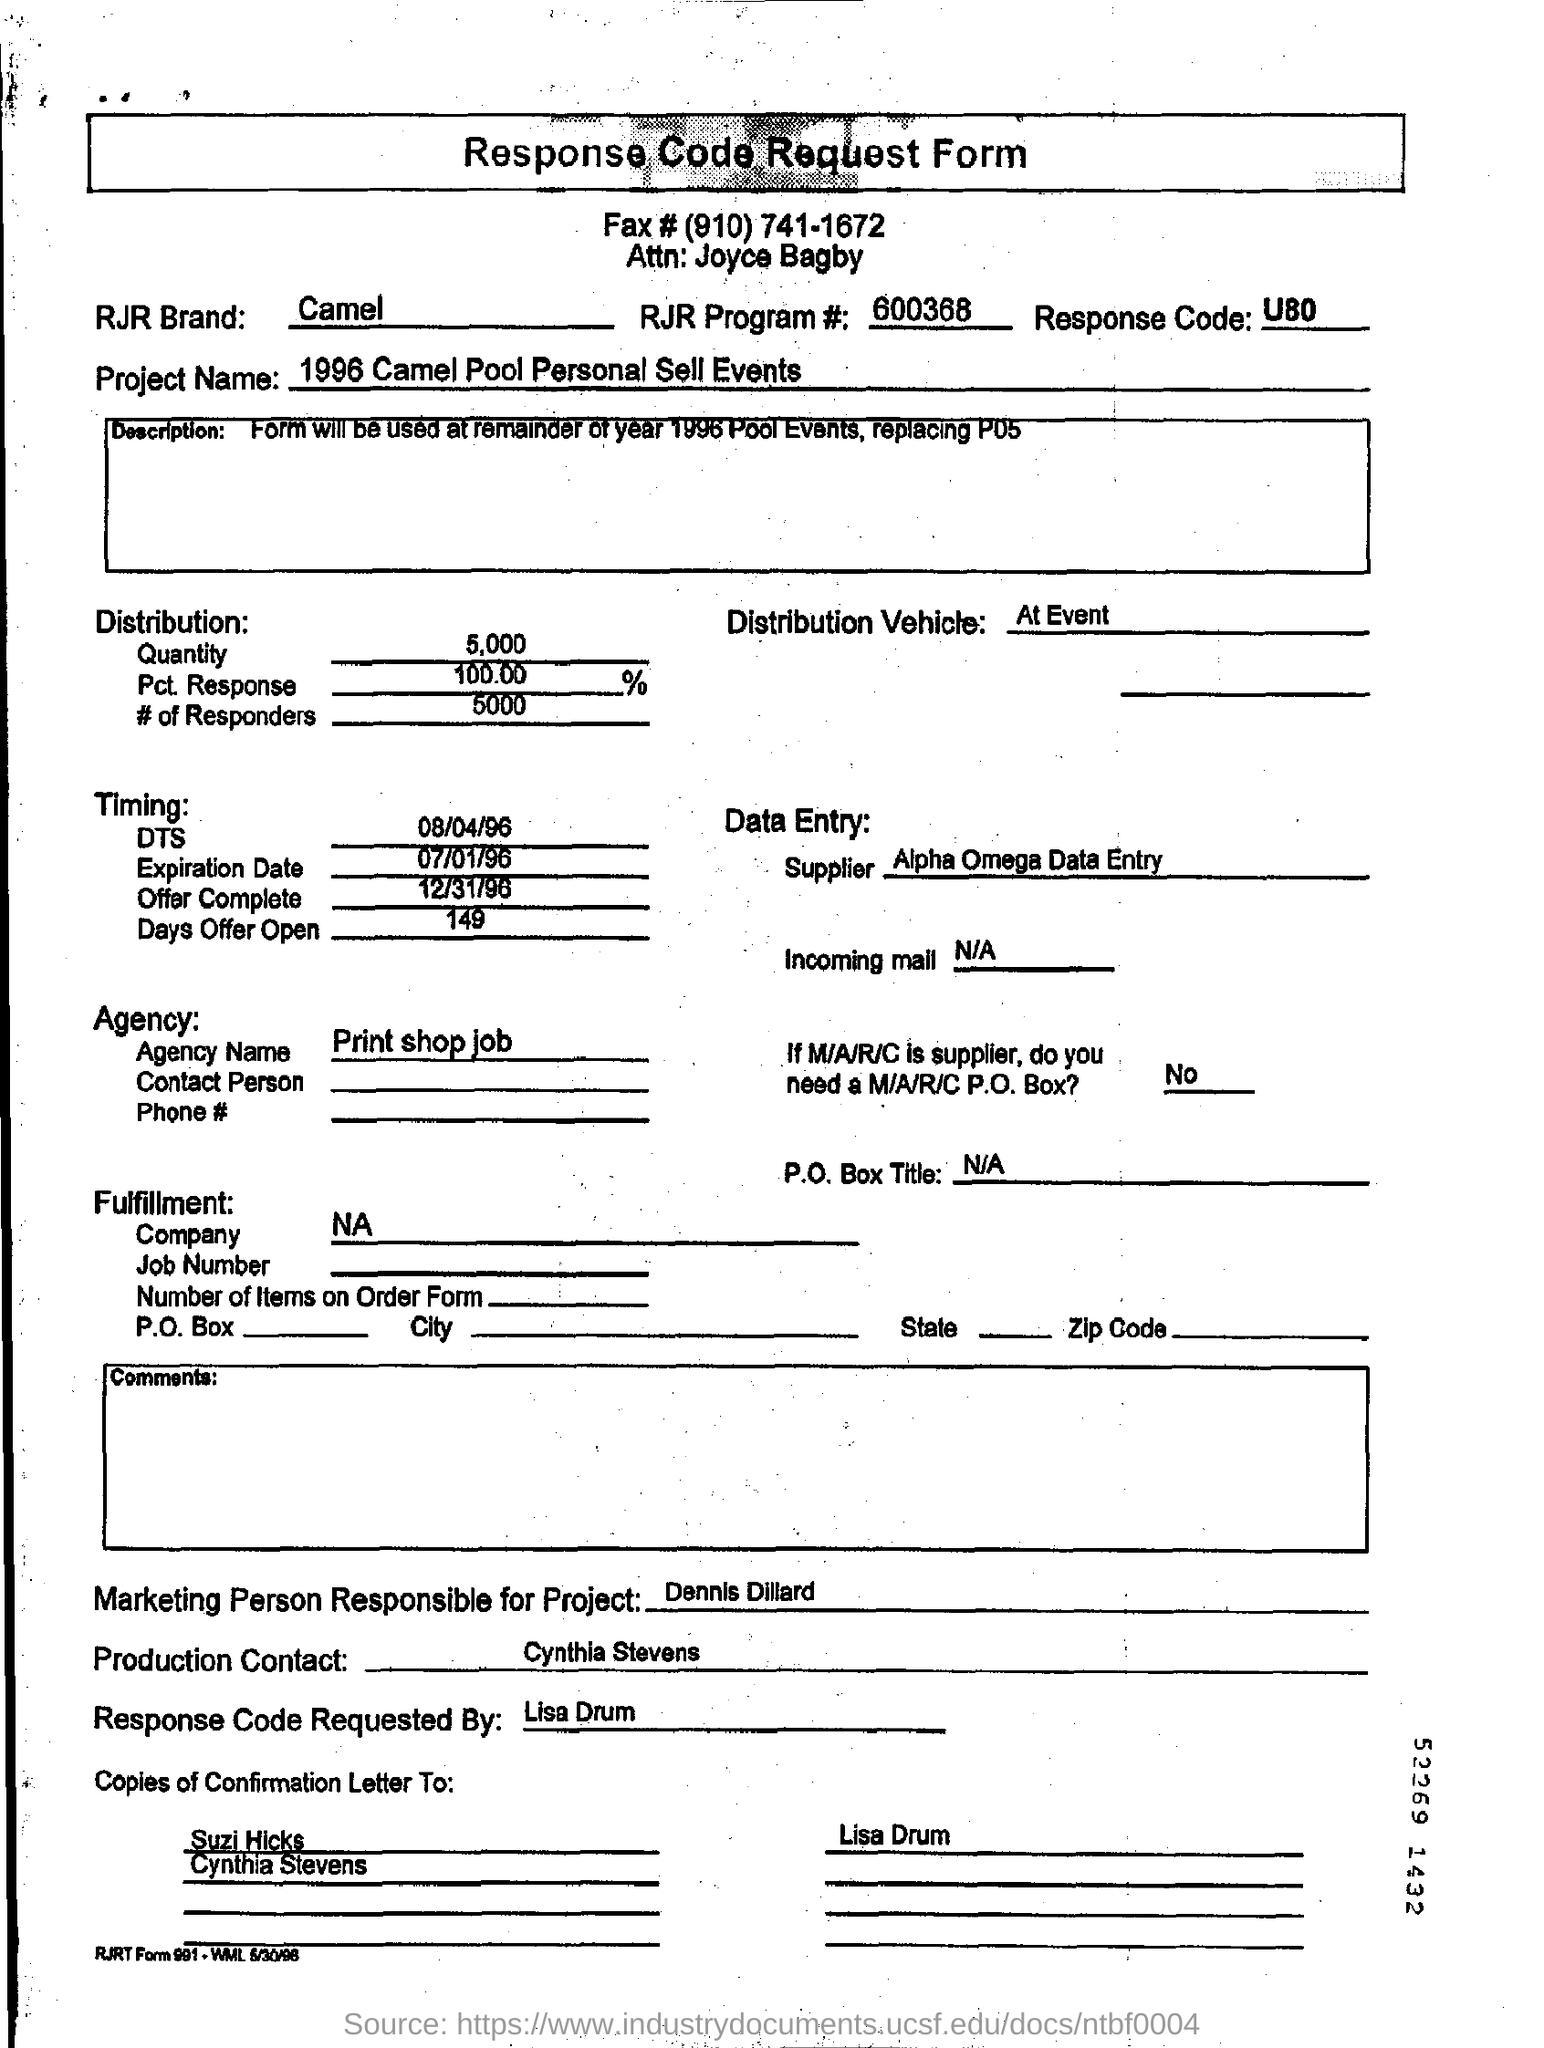Highlight a few significant elements in this photo. The individual designated as Dennis Dillard is responsible for the marketing aspect of this project. The production contact is Cynthia Stevens. What is the 'Response Code' mentioned in the form? It is a code that provides information about the outcome of a particular action or request, such as a response to a survey or a transaction completed on a website. The "Offer Complete" date mentioned under "Timing:" is December 31, 1996. RJR Brand is a reference to a product that is known as a "CAMEL. 